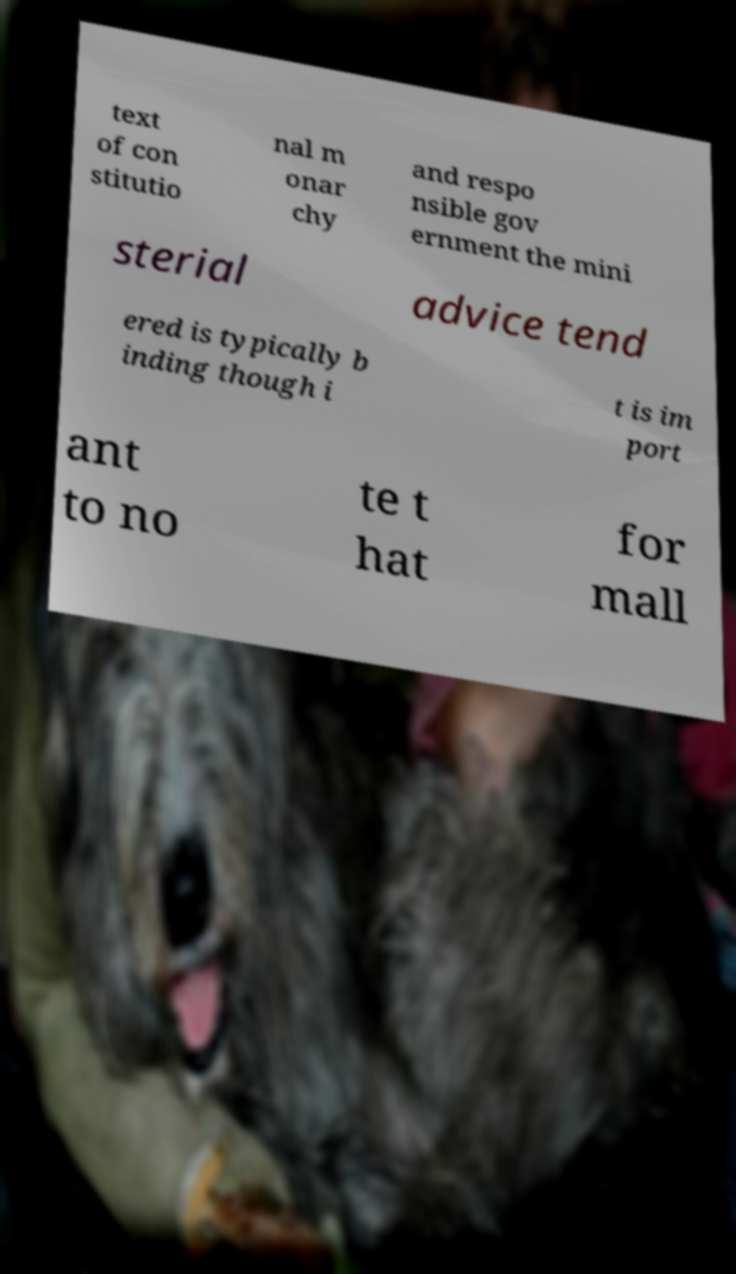Please read and relay the text visible in this image. What does it say? text of con stitutio nal m onar chy and respo nsible gov ernment the mini sterial advice tend ered is typically b inding though i t is im port ant to no te t hat for mall 